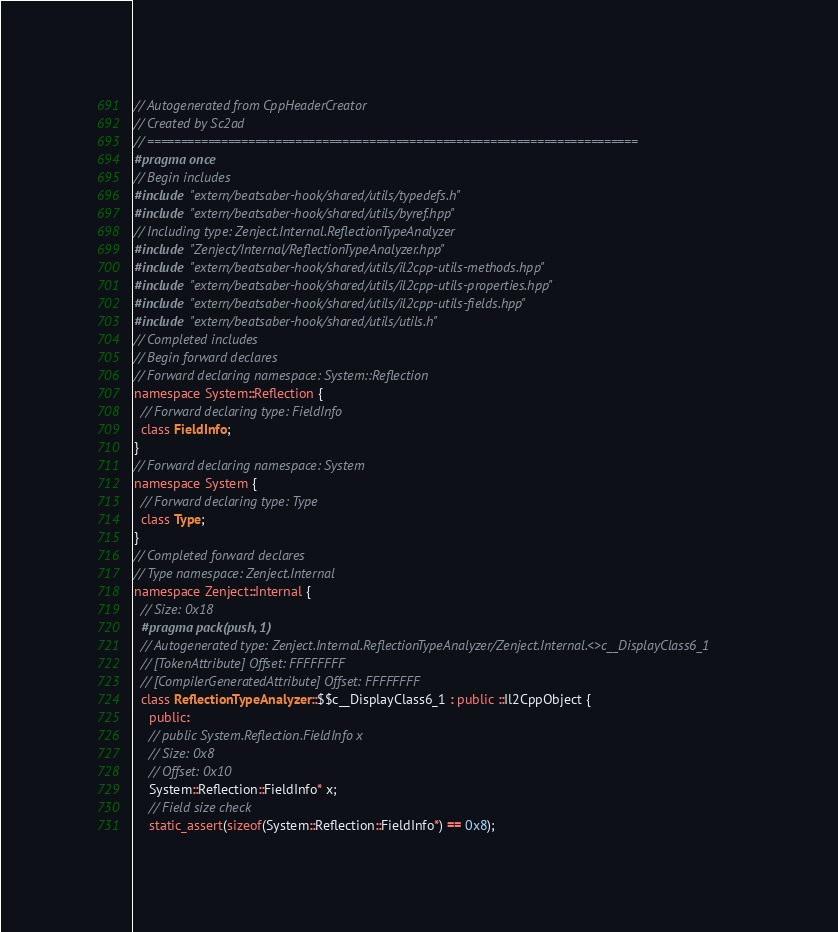Convert code to text. <code><loc_0><loc_0><loc_500><loc_500><_C++_>// Autogenerated from CppHeaderCreator
// Created by Sc2ad
// =========================================================================
#pragma once
// Begin includes
#include "extern/beatsaber-hook/shared/utils/typedefs.h"
#include "extern/beatsaber-hook/shared/utils/byref.hpp"
// Including type: Zenject.Internal.ReflectionTypeAnalyzer
#include "Zenject/Internal/ReflectionTypeAnalyzer.hpp"
#include "extern/beatsaber-hook/shared/utils/il2cpp-utils-methods.hpp"
#include "extern/beatsaber-hook/shared/utils/il2cpp-utils-properties.hpp"
#include "extern/beatsaber-hook/shared/utils/il2cpp-utils-fields.hpp"
#include "extern/beatsaber-hook/shared/utils/utils.h"
// Completed includes
// Begin forward declares
// Forward declaring namespace: System::Reflection
namespace System::Reflection {
  // Forward declaring type: FieldInfo
  class FieldInfo;
}
// Forward declaring namespace: System
namespace System {
  // Forward declaring type: Type
  class Type;
}
// Completed forward declares
// Type namespace: Zenject.Internal
namespace Zenject::Internal {
  // Size: 0x18
  #pragma pack(push, 1)
  // Autogenerated type: Zenject.Internal.ReflectionTypeAnalyzer/Zenject.Internal.<>c__DisplayClass6_1
  // [TokenAttribute] Offset: FFFFFFFF
  // [CompilerGeneratedAttribute] Offset: FFFFFFFF
  class ReflectionTypeAnalyzer::$$c__DisplayClass6_1 : public ::Il2CppObject {
    public:
    // public System.Reflection.FieldInfo x
    // Size: 0x8
    // Offset: 0x10
    System::Reflection::FieldInfo* x;
    // Field size check
    static_assert(sizeof(System::Reflection::FieldInfo*) == 0x8);</code> 